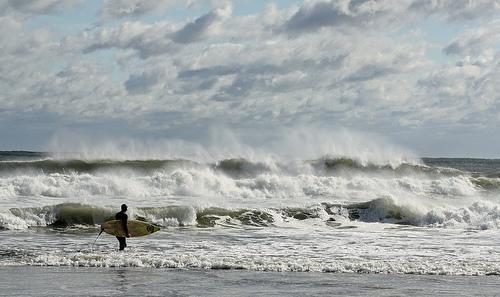How many people are pictured?
Give a very brief answer. 1. 